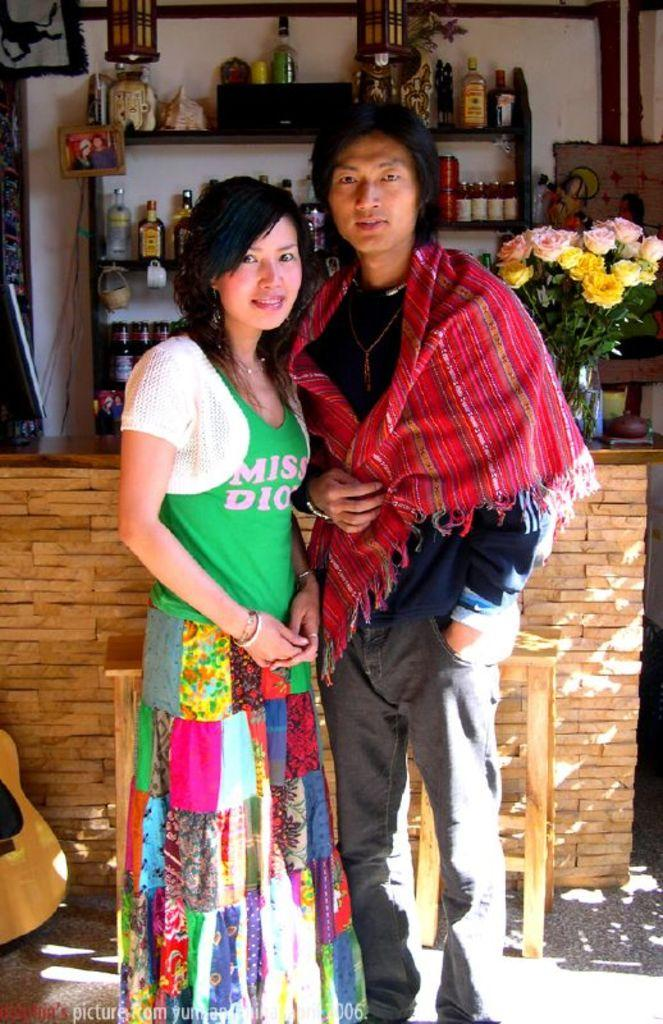Who is present in the image? There is a man and a woman in the image. What are the man and woman doing in the image? The man and woman are standing together and smiling. What can be seen in the background of the image? There is a table and a shelf with glass bottles in the background of the image. What type of roof can be seen on the building in the image? There is no building or roof present in the image; it features a man and a woman standing together. How many balloons are tied to the woman's wrist in the image? There are no balloons present in the image. 